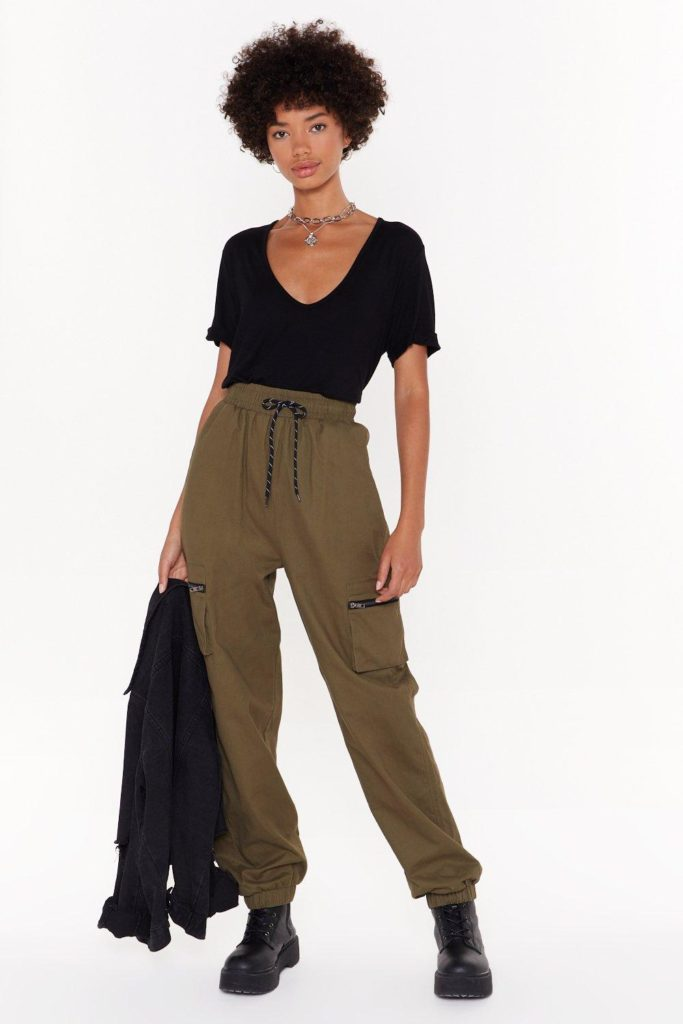How does the lighting in the photograph affect the perception of the colors in the individual's clothing? The lighting in this photograph is bright and evenly distributed, which enhances the clarity and accurate depiction of the colors in the individual's clothing. The black T-shirt is displayed without any color distortion, appearing true to its color without reflections or shadows that could alter its appearance. The olive green cargo pants are also well-represented, with the shadows within the fabric folds adding depth and emphasizing the natural color of the pants. The light background doesn't introduce any color shifts onto the clothing, ensuring that the colors remain as they would appear in person. Additionally, the black boots and the denim jacket held by the individual maintain their authentic black color under the current lighting, which contributes to a consistent and undistorted color perception throughout the entire photo. 